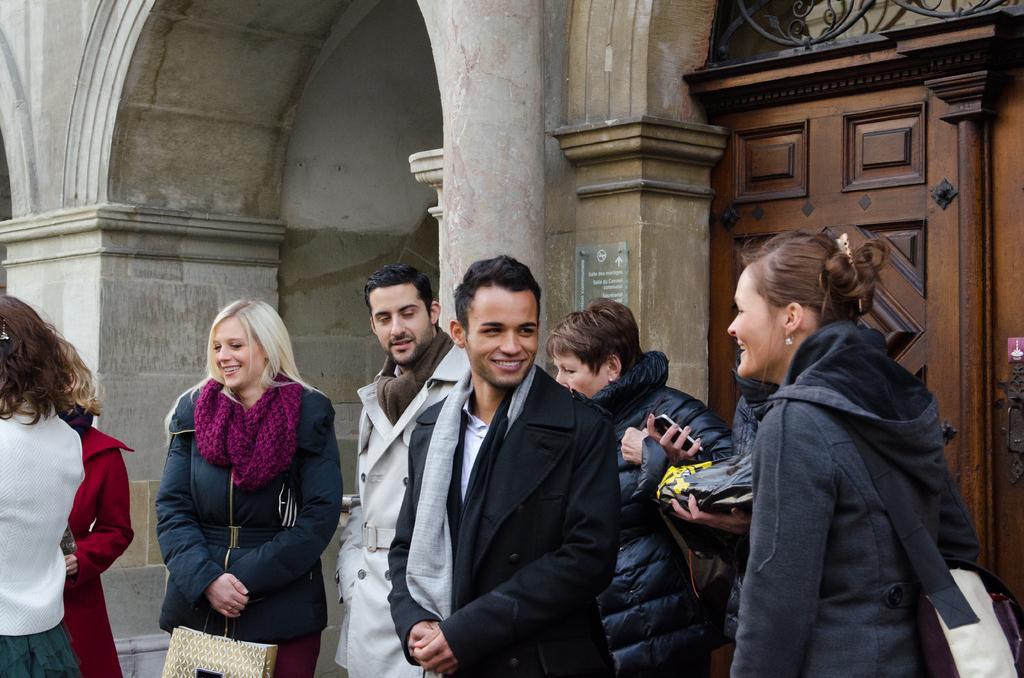Could you give a brief overview of what you see in this image? This picture is clicked outside the city. Here, we see many people standing on the road and all of them are smiling. Behind them, we see a brown color door and beside that, we see a building which is white in color. 